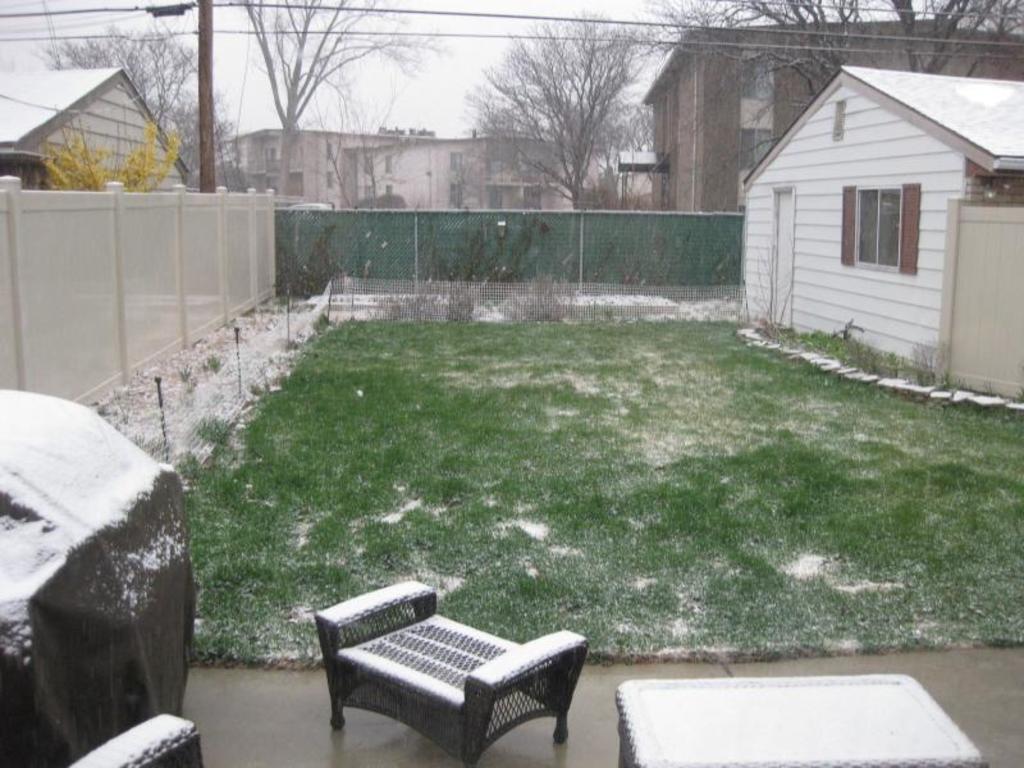How would you summarize this image in a sentence or two? In this picture I can see few buildings, trees and I can see grass on the ground and I can see snow, a chair and a table 